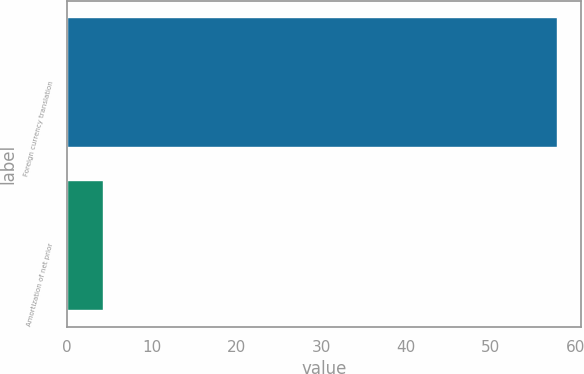Convert chart to OTSL. <chart><loc_0><loc_0><loc_500><loc_500><bar_chart><fcel>Foreign currency translation<fcel>Amortization of net prior<nl><fcel>57.8<fcel>4.2<nl></chart> 